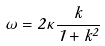<formula> <loc_0><loc_0><loc_500><loc_500>\omega = 2 \kappa \frac { k } { 1 + k ^ { 2 } }</formula> 